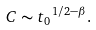<formula> <loc_0><loc_0><loc_500><loc_500>C \sim { t _ { 0 } } ^ { 1 / 2 - \beta } .</formula> 